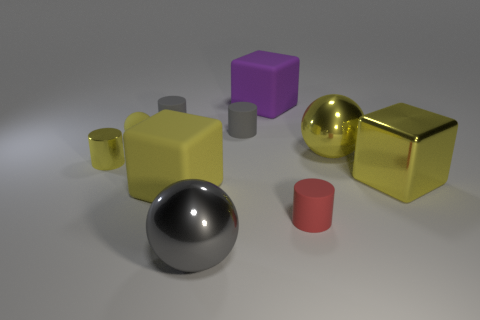What is the color of the metal cylinder that is the same size as the rubber ball?
Provide a succinct answer. Yellow. How many purple objects have the same shape as the red thing?
Make the answer very short. 0. Do the rubber ball and the matte cylinder that is in front of the small yellow cylinder have the same size?
Your response must be concise. Yes. What shape is the tiny gray rubber object that is right of the matte block that is left of the purple object?
Make the answer very short. Cylinder. Is the number of big metallic balls that are in front of the tiny yellow metallic thing less than the number of large yellow matte blocks?
Ensure brevity in your answer.  No. What shape is the tiny thing that is the same color as the tiny metallic cylinder?
Ensure brevity in your answer.  Sphere. How many green shiny spheres are the same size as the yellow metallic ball?
Give a very brief answer. 0. The gray object in front of the small red rubber thing has what shape?
Provide a short and direct response. Sphere. Are there fewer yellow balls than gray matte cubes?
Give a very brief answer. No. Is there any other thing that is the same color as the small metal cylinder?
Provide a succinct answer. Yes. 